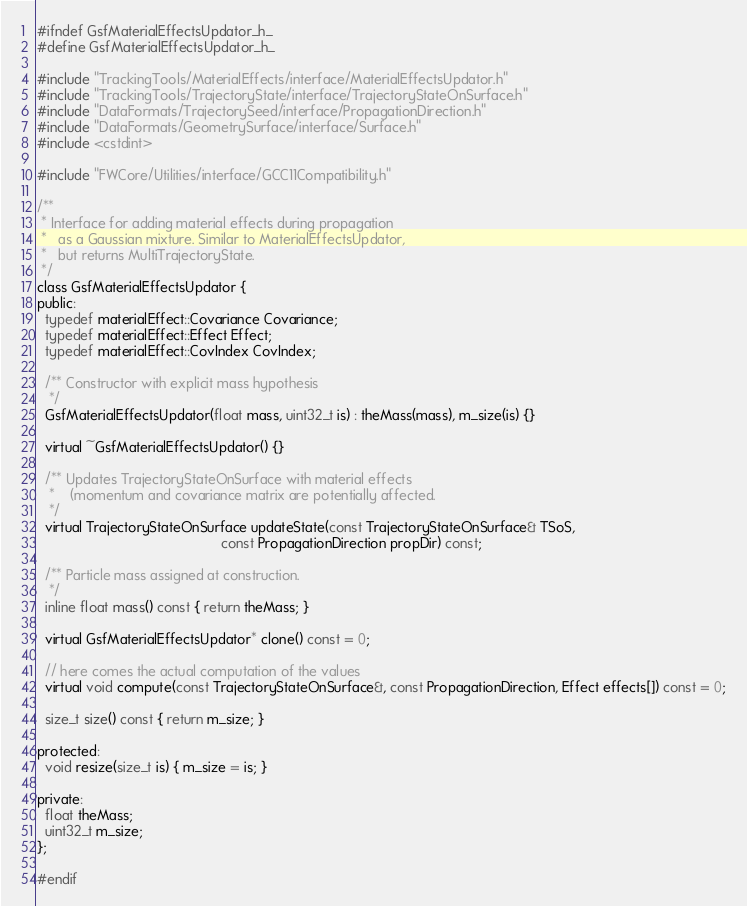Convert code to text. <code><loc_0><loc_0><loc_500><loc_500><_C_>#ifndef GsfMaterialEffectsUpdator_h_
#define GsfMaterialEffectsUpdator_h_

#include "TrackingTools/MaterialEffects/interface/MaterialEffectsUpdator.h"
#include "TrackingTools/TrajectoryState/interface/TrajectoryStateOnSurface.h"
#include "DataFormats/TrajectorySeed/interface/PropagationDirection.h"
#include "DataFormats/GeometrySurface/interface/Surface.h"
#include <cstdint>

#include "FWCore/Utilities/interface/GCC11Compatibility.h"

/**
 * Interface for adding material effects during propagation
 *   as a Gaussian mixture. Similar to MaterialEffectsUpdator,
 *   but returns MultiTrajectoryState.
 */
class GsfMaterialEffectsUpdator {
public:
  typedef materialEffect::Covariance Covariance;
  typedef materialEffect::Effect Effect;
  typedef materialEffect::CovIndex CovIndex;

  /** Constructor with explicit mass hypothesis
   */
  GsfMaterialEffectsUpdator(float mass, uint32_t is) : theMass(mass), m_size(is) {}

  virtual ~GsfMaterialEffectsUpdator() {}

  /** Updates TrajectoryStateOnSurface with material effects
   *    (momentum and covariance matrix are potentially affected.
   */
  virtual TrajectoryStateOnSurface updateState(const TrajectoryStateOnSurface& TSoS,
                                               const PropagationDirection propDir) const;

  /** Particle mass assigned at construction.
   */
  inline float mass() const { return theMass; }

  virtual GsfMaterialEffectsUpdator* clone() const = 0;

  // here comes the actual computation of the values
  virtual void compute(const TrajectoryStateOnSurface&, const PropagationDirection, Effect effects[]) const = 0;

  size_t size() const { return m_size; }

protected:
  void resize(size_t is) { m_size = is; }

private:
  float theMass;
  uint32_t m_size;
};

#endif
</code> 